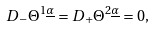Convert formula to latex. <formula><loc_0><loc_0><loc_500><loc_500>D _ { - } \Theta ^ { 1 \underline { \alpha } } = D _ { + } \Theta ^ { 2 \underline { \alpha } } = 0 ,</formula> 